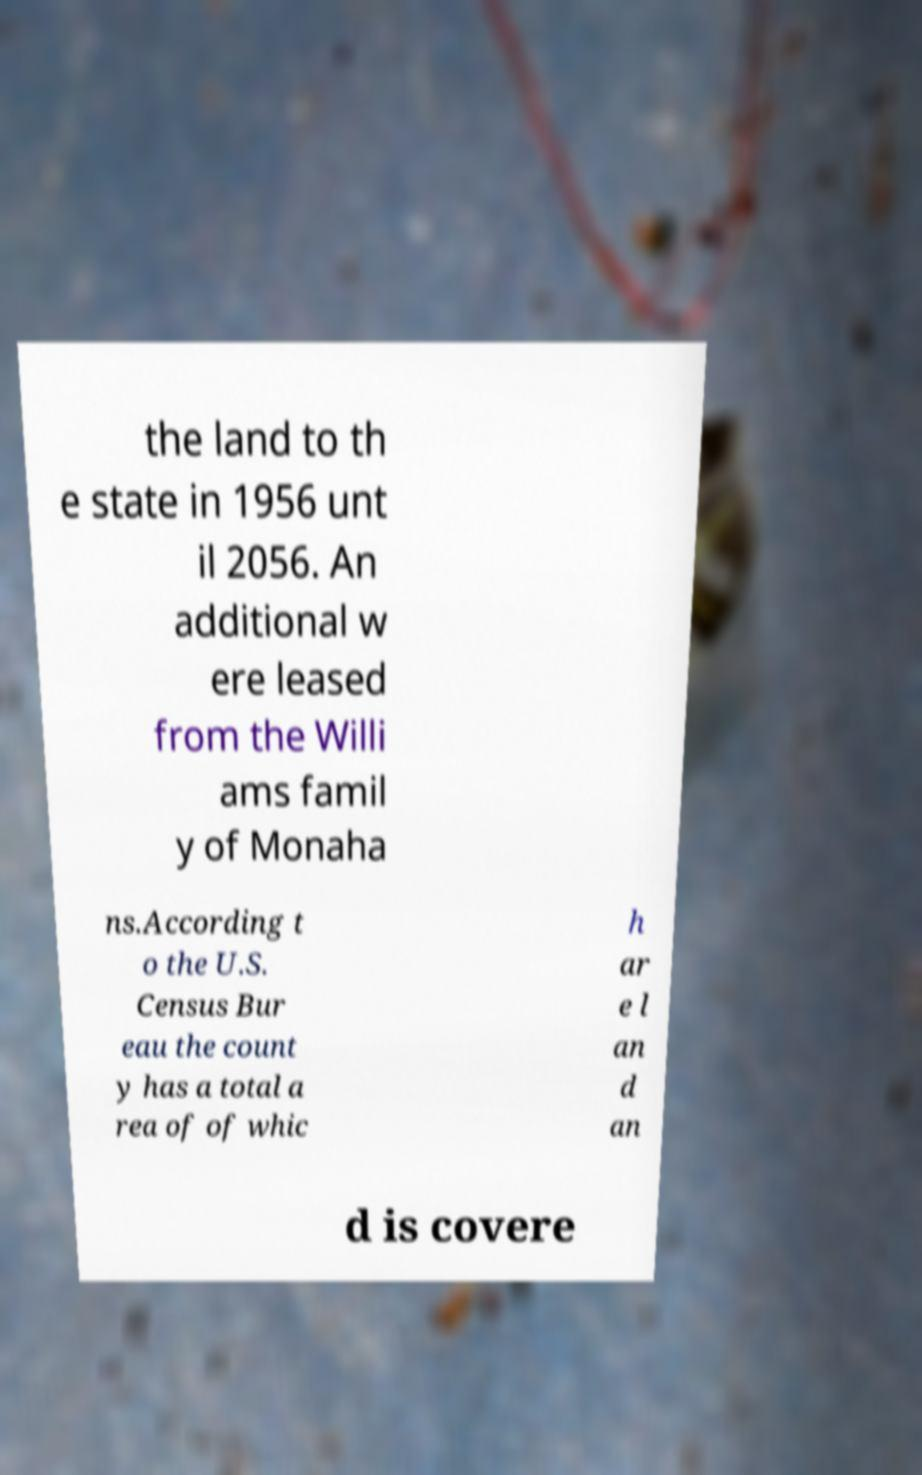What messages or text are displayed in this image? I need them in a readable, typed format. the land to th e state in 1956 unt il 2056. An additional w ere leased from the Willi ams famil y of Monaha ns.According t o the U.S. Census Bur eau the count y has a total a rea of of whic h ar e l an d an d is covere 